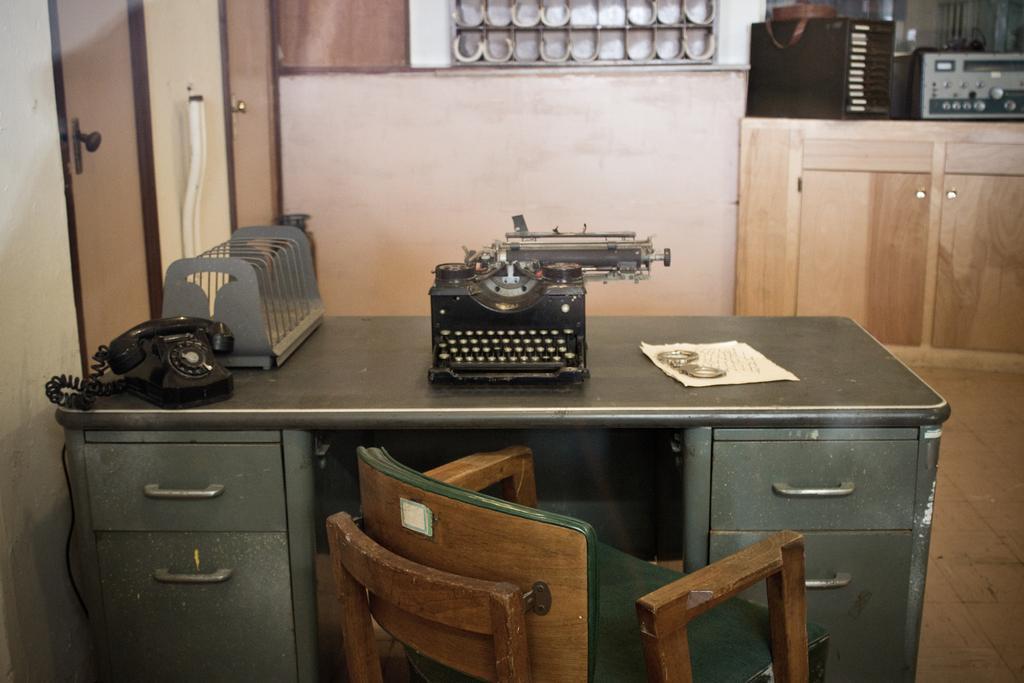In one or two sentences, can you explain what this image depicts? In this image there is a chair. In front of the chair there is a table. On top of it there is a landline phone, paper and a few other objects. On the left side of the image there are doors. At the bottom of the image there is a floor. There are wooden cupboards. On top of it there are some objects. 